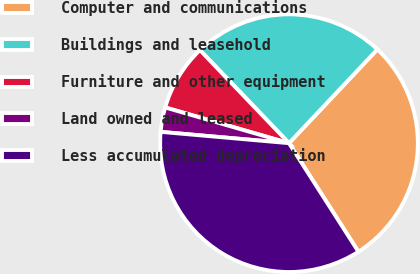Convert chart to OTSL. <chart><loc_0><loc_0><loc_500><loc_500><pie_chart><fcel>Computer and communications<fcel>Buildings and leasehold<fcel>Furniture and other equipment<fcel>Land owned and leased<fcel>Less accumulated depreciation<nl><fcel>28.92%<fcel>24.18%<fcel>8.38%<fcel>3.07%<fcel>35.46%<nl></chart> 